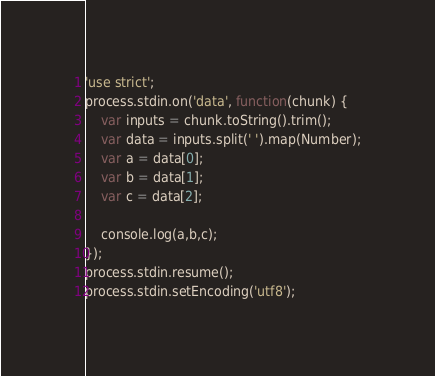Convert code to text. <code><loc_0><loc_0><loc_500><loc_500><_JavaScript_>'use strict';
process.stdin.on('data', function(chunk) {
    var inputs = chunk.toString().trim();
    var data = inputs.split(' ').map(Number);
    var a = data[0];
    var b = data[1];
    var c = data[2];

    console.log(a,b,c);
});
process.stdin.resume();
process.stdin.setEncoding('utf8');</code> 